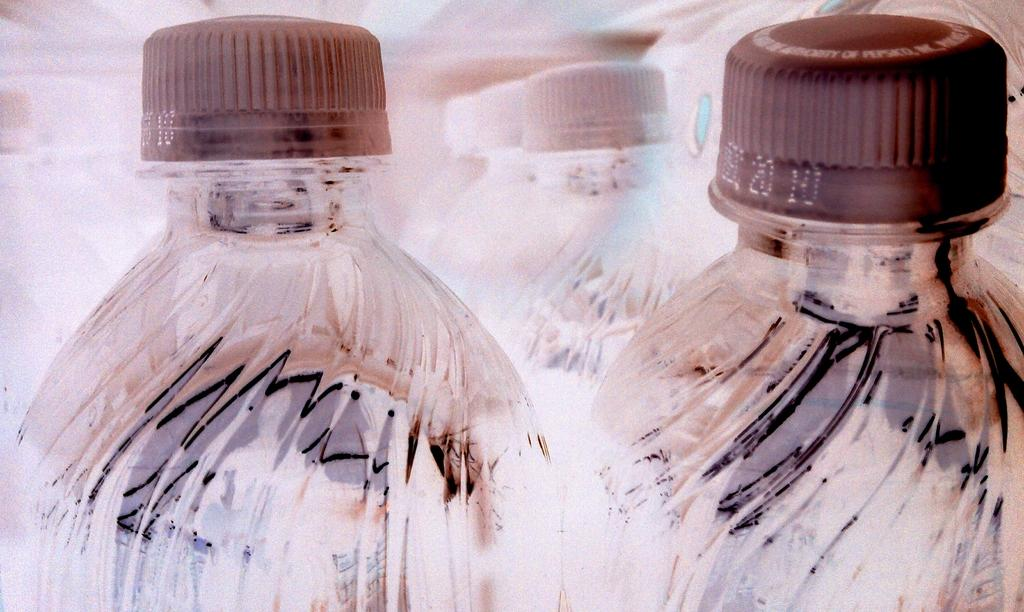What is the main subject of the image? The main subject of the image is many bottles. Can you describe the caps of the bottles in the front? The two bottles in the front have brown color caps. How about the caps of the bottles in the background? The remaining bottles in the background have white color caps. What type of pie is being served on the stem of the bottle in the image? There is no pie or stem present in the image; it only features bottles with caps. 